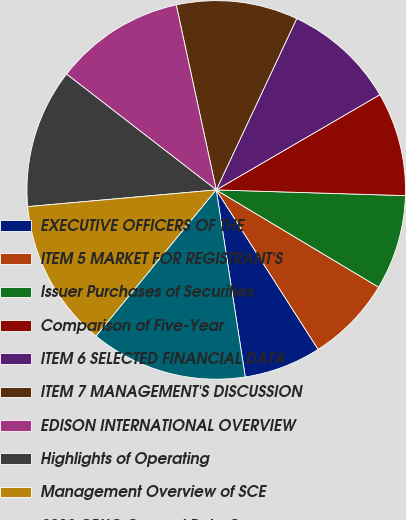Convert chart. <chart><loc_0><loc_0><loc_500><loc_500><pie_chart><fcel>EXECUTIVE OFFICERS OF THE<fcel>ITEM 5 MARKET FOR REGISTRANT'S<fcel>Issuer Purchases of Securities<fcel>Comparison of Five-Year<fcel>ITEM 6 SELECTED FINANCIAL DATA<fcel>ITEM 7 MANAGEMENT'S DISCUSSION<fcel>EDISON INTERNATIONAL OVERVIEW<fcel>Highlights of Operating<fcel>Management Overview of SCE<fcel>2012 CPUC General Rate Case<nl><fcel>6.6%<fcel>7.36%<fcel>8.11%<fcel>8.87%<fcel>9.62%<fcel>10.38%<fcel>11.13%<fcel>11.89%<fcel>12.64%<fcel>13.4%<nl></chart> 